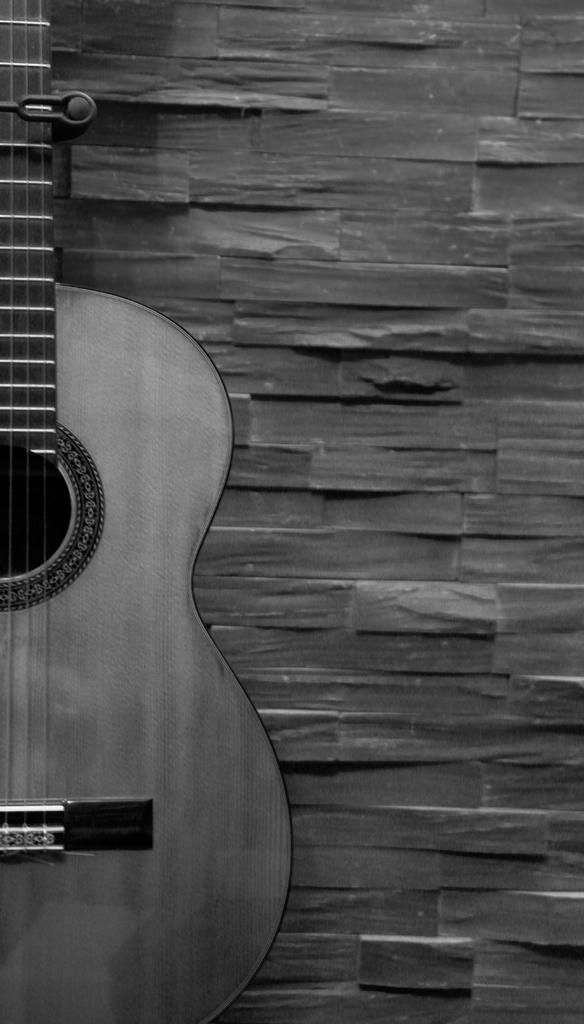Could you give a brief overview of what you see in this image? Here we can see a guitar placed towards the wall and here we can see a wall with a different design 